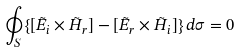<formula> <loc_0><loc_0><loc_500><loc_500>\oint _ { S } \left \{ [ \tilde { E } _ { i } \times \tilde { H } _ { r } ] - [ \tilde { E } _ { r } \times \tilde { H } _ { i } ] \right \} d { \sigma } = 0</formula> 